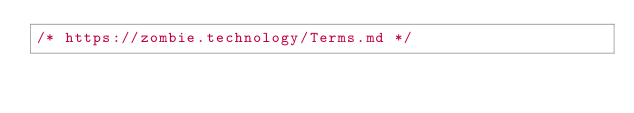Convert code to text. <code><loc_0><loc_0><loc_500><loc_500><_CSS_>/* https://zombie.technology/Terms.md */</code> 